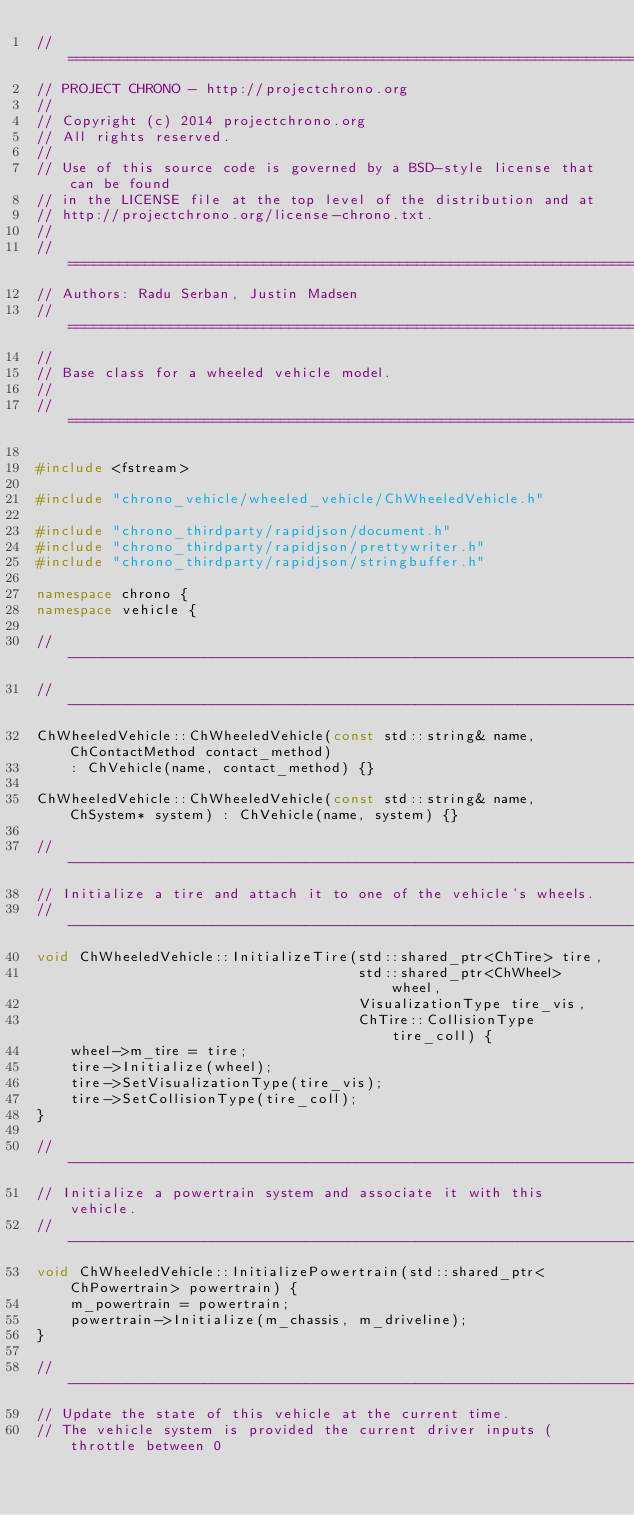Convert code to text. <code><loc_0><loc_0><loc_500><loc_500><_C++_>// =============================================================================
// PROJECT CHRONO - http://projectchrono.org
//
// Copyright (c) 2014 projectchrono.org
// All rights reserved.
//
// Use of this source code is governed by a BSD-style license that can be found
// in the LICENSE file at the top level of the distribution and at
// http://projectchrono.org/license-chrono.txt.
//
// =============================================================================
// Authors: Radu Serban, Justin Madsen
// =============================================================================
//
// Base class for a wheeled vehicle model.
//
// =============================================================================

#include <fstream>

#include "chrono_vehicle/wheeled_vehicle/ChWheeledVehicle.h"

#include "chrono_thirdparty/rapidjson/document.h"
#include "chrono_thirdparty/rapidjson/prettywriter.h"
#include "chrono_thirdparty/rapidjson/stringbuffer.h"

namespace chrono {
namespace vehicle {

// -----------------------------------------------------------------------------
// -----------------------------------------------------------------------------
ChWheeledVehicle::ChWheeledVehicle(const std::string& name, ChContactMethod contact_method)
    : ChVehicle(name, contact_method) {}

ChWheeledVehicle::ChWheeledVehicle(const std::string& name, ChSystem* system) : ChVehicle(name, system) {}

// -----------------------------------------------------------------------------
// Initialize a tire and attach it to one of the vehicle's wheels.
// -----------------------------------------------------------------------------
void ChWheeledVehicle::InitializeTire(std::shared_ptr<ChTire> tire,
                                      std::shared_ptr<ChWheel> wheel,
                                      VisualizationType tire_vis,
                                      ChTire::CollisionType tire_coll) {
    wheel->m_tire = tire;
    tire->Initialize(wheel);
    tire->SetVisualizationType(tire_vis);
    tire->SetCollisionType(tire_coll);
}

// -----------------------------------------------------------------------------
// Initialize a powertrain system and associate it with this vehicle.
// -----------------------------------------------------------------------------
void ChWheeledVehicle::InitializePowertrain(std::shared_ptr<ChPowertrain> powertrain) {
    m_powertrain = powertrain;
    powertrain->Initialize(m_chassis, m_driveline);
}

// -----------------------------------------------------------------------------
// Update the state of this vehicle at the current time.
// The vehicle system is provided the current driver inputs (throttle between 0</code> 